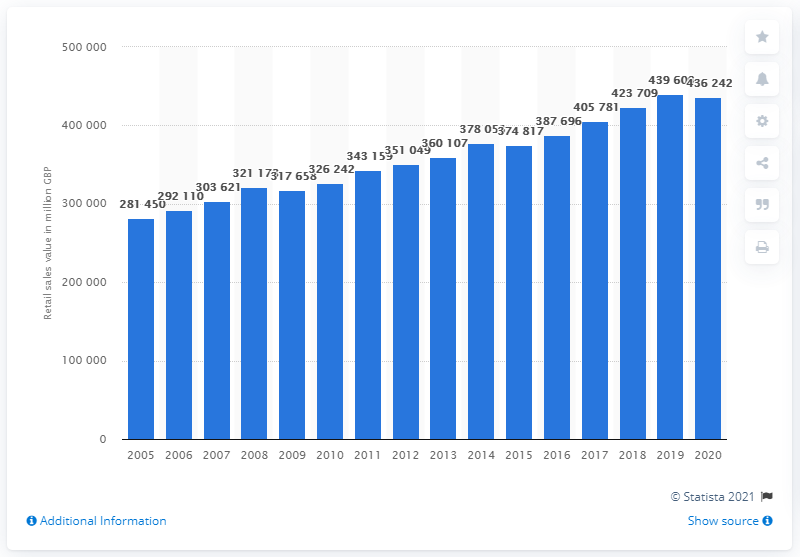Specify some key components in this picture. In 2019, the retail industry, excluding fuel sales, achieved a record high value. 